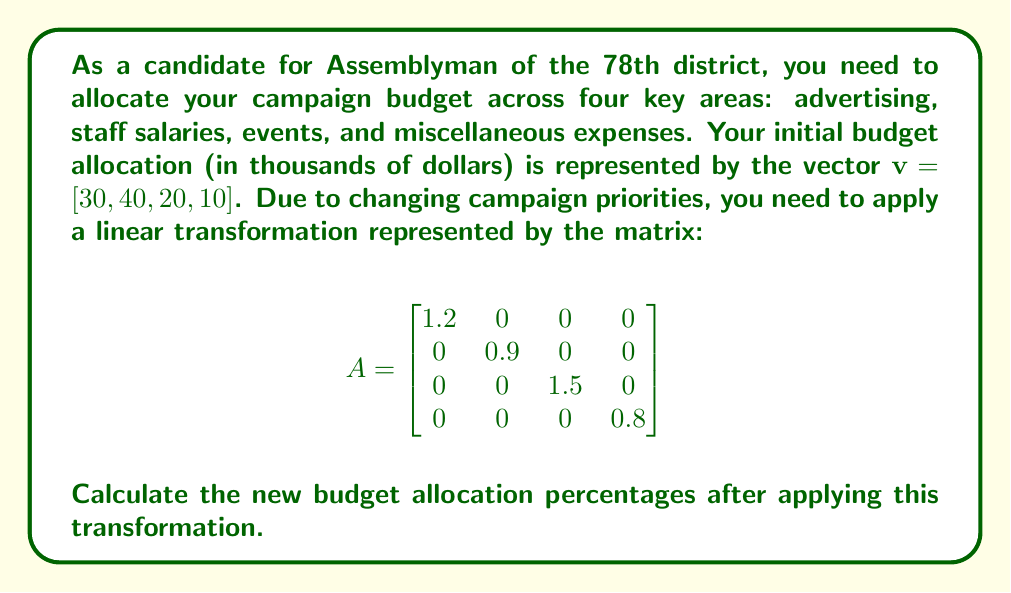Can you solve this math problem? To solve this problem, we'll follow these steps:

1) First, we need to apply the linear transformation to our initial budget vector. This is done by multiplying the matrix $A$ by the vector $\mathbf{v}$:

   $$A\mathbf{v} = \begin{bmatrix}
   1.2 & 0 & 0 & 0 \\
   0 & 0.9 & 0 & 0 \\
   0 & 0 & 1.5 & 0 \\
   0 & 0 & 0 & 0.8
   \end{bmatrix} \begin{bmatrix} 30 \\ 40 \\ 20 \\ 10 \end{bmatrix}$$

2) Performing the matrix multiplication:

   $$A\mathbf{v} = \begin{bmatrix}
   1.2(30) \\
   0.9(40) \\
   1.5(20) \\
   0.8(10)
   \end{bmatrix} = \begin{bmatrix}
   36 \\
   36 \\
   30 \\
   8
   \end{bmatrix}$$

3) Now we have our new budget allocation in thousands of dollars. To convert this to percentages, we first need to find the total budget:

   $36 + 36 + 30 + 8 = 110$ thousand dollars

4) Then we calculate each percentage by dividing each amount by the total and multiplying by 100:

   Advertising: $(36 / 110) * 100 = 32.73\%$
   Staff salaries: $(36 / 110) * 100 = 32.73\%$
   Events: $(30 / 110) * 100 = 27.27\%$
   Miscellaneous: $(8 / 110) * 100 = 7.27\%$

5) We can verify that these percentages sum to 100%.
Answer: $[32.73\%, 32.73\%, 27.27\%, 7.27\%]$ 